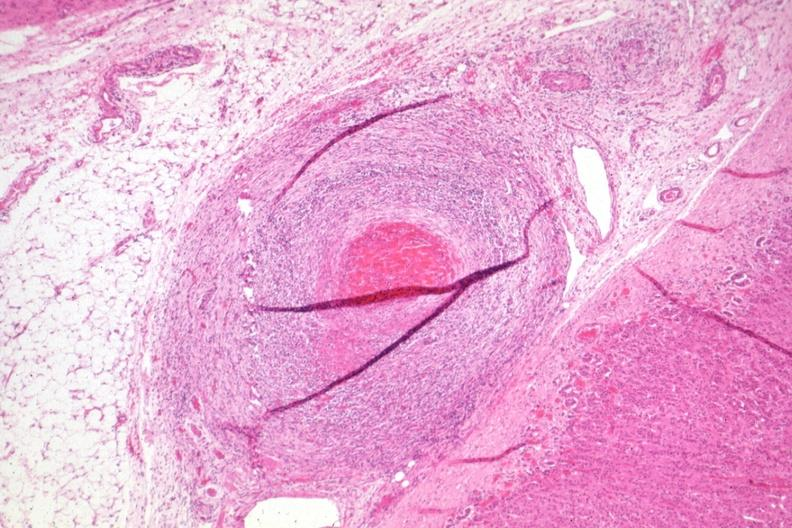where is this part in the figure?
Answer the question using a single word or phrase. Endocrine system 